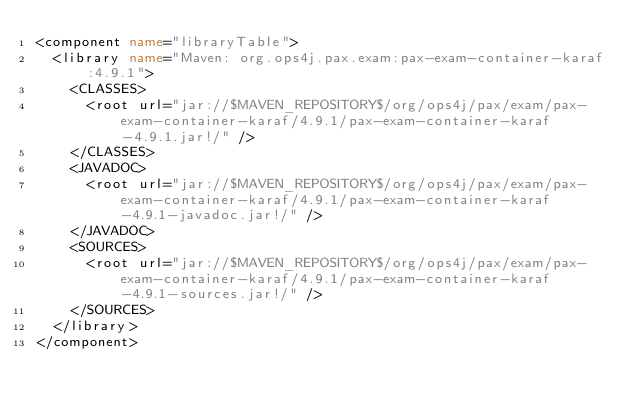Convert code to text. <code><loc_0><loc_0><loc_500><loc_500><_XML_><component name="libraryTable">
  <library name="Maven: org.ops4j.pax.exam:pax-exam-container-karaf:4.9.1">
    <CLASSES>
      <root url="jar://$MAVEN_REPOSITORY$/org/ops4j/pax/exam/pax-exam-container-karaf/4.9.1/pax-exam-container-karaf-4.9.1.jar!/" />
    </CLASSES>
    <JAVADOC>
      <root url="jar://$MAVEN_REPOSITORY$/org/ops4j/pax/exam/pax-exam-container-karaf/4.9.1/pax-exam-container-karaf-4.9.1-javadoc.jar!/" />
    </JAVADOC>
    <SOURCES>
      <root url="jar://$MAVEN_REPOSITORY$/org/ops4j/pax/exam/pax-exam-container-karaf/4.9.1/pax-exam-container-karaf-4.9.1-sources.jar!/" />
    </SOURCES>
  </library>
</component></code> 